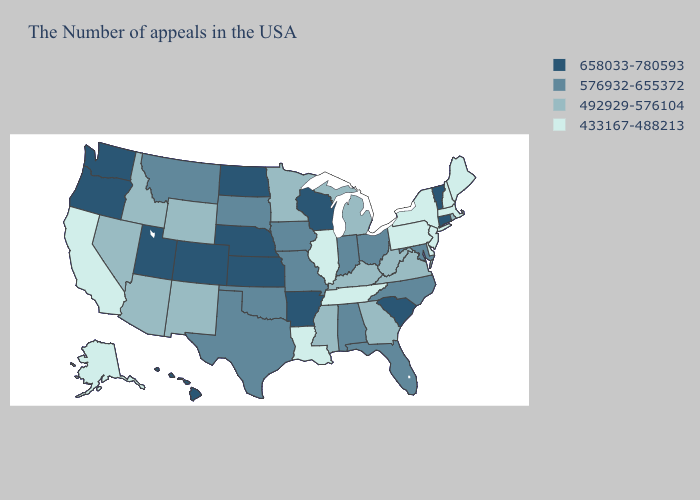Does Maine have the highest value in the Northeast?
Concise answer only. No. Name the states that have a value in the range 433167-488213?
Quick response, please. Maine, Massachusetts, New Hampshire, New York, New Jersey, Delaware, Pennsylvania, Tennessee, Illinois, Louisiana, California, Alaska. What is the lowest value in the MidWest?
Keep it brief. 433167-488213. What is the value of Michigan?
Concise answer only. 492929-576104. Name the states that have a value in the range 492929-576104?
Keep it brief. Rhode Island, Virginia, West Virginia, Georgia, Michigan, Kentucky, Mississippi, Minnesota, Wyoming, New Mexico, Arizona, Idaho, Nevada. What is the highest value in the West ?
Give a very brief answer. 658033-780593. Name the states that have a value in the range 433167-488213?
Be succinct. Maine, Massachusetts, New Hampshire, New York, New Jersey, Delaware, Pennsylvania, Tennessee, Illinois, Louisiana, California, Alaska. What is the value of Minnesota?
Keep it brief. 492929-576104. Does West Virginia have a lower value than Georgia?
Answer briefly. No. What is the lowest value in the Northeast?
Answer briefly. 433167-488213. Name the states that have a value in the range 658033-780593?
Keep it brief. Vermont, Connecticut, South Carolina, Wisconsin, Arkansas, Kansas, Nebraska, North Dakota, Colorado, Utah, Washington, Oregon, Hawaii. Among the states that border Montana , does Idaho have the lowest value?
Keep it brief. Yes. Which states have the highest value in the USA?
Concise answer only. Vermont, Connecticut, South Carolina, Wisconsin, Arkansas, Kansas, Nebraska, North Dakota, Colorado, Utah, Washington, Oregon, Hawaii. What is the value of Maine?
Short answer required. 433167-488213. What is the highest value in states that border Ohio?
Be succinct. 576932-655372. 